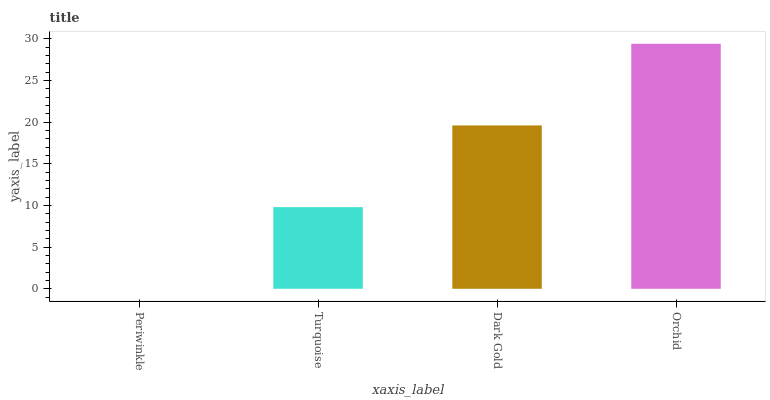Is Periwinkle the minimum?
Answer yes or no. Yes. Is Orchid the maximum?
Answer yes or no. Yes. Is Turquoise the minimum?
Answer yes or no. No. Is Turquoise the maximum?
Answer yes or no. No. Is Turquoise greater than Periwinkle?
Answer yes or no. Yes. Is Periwinkle less than Turquoise?
Answer yes or no. Yes. Is Periwinkle greater than Turquoise?
Answer yes or no. No. Is Turquoise less than Periwinkle?
Answer yes or no. No. Is Dark Gold the high median?
Answer yes or no. Yes. Is Turquoise the low median?
Answer yes or no. Yes. Is Periwinkle the high median?
Answer yes or no. No. Is Dark Gold the low median?
Answer yes or no. No. 